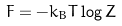<formula> <loc_0><loc_0><loc_500><loc_500>F = - k _ { B } T \log Z</formula> 